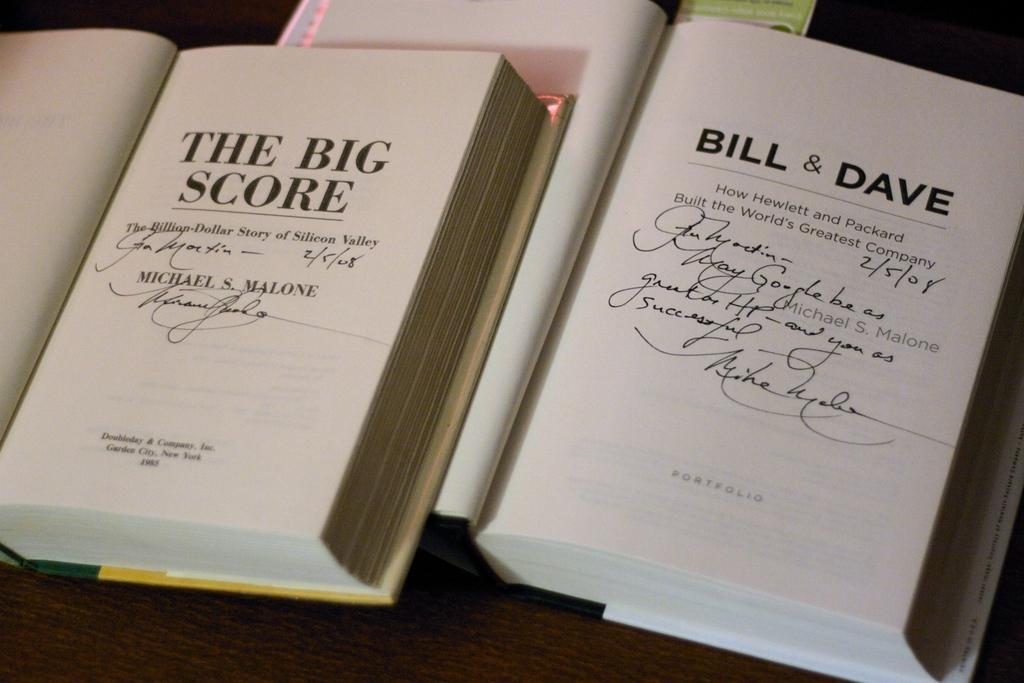<image>
Present a compact description of the photo's key features. A pair of books relay the stories of how the Silicon Valley came about and also the story of how Hewlett and Packard the people created Hewlett-Packard the company. 